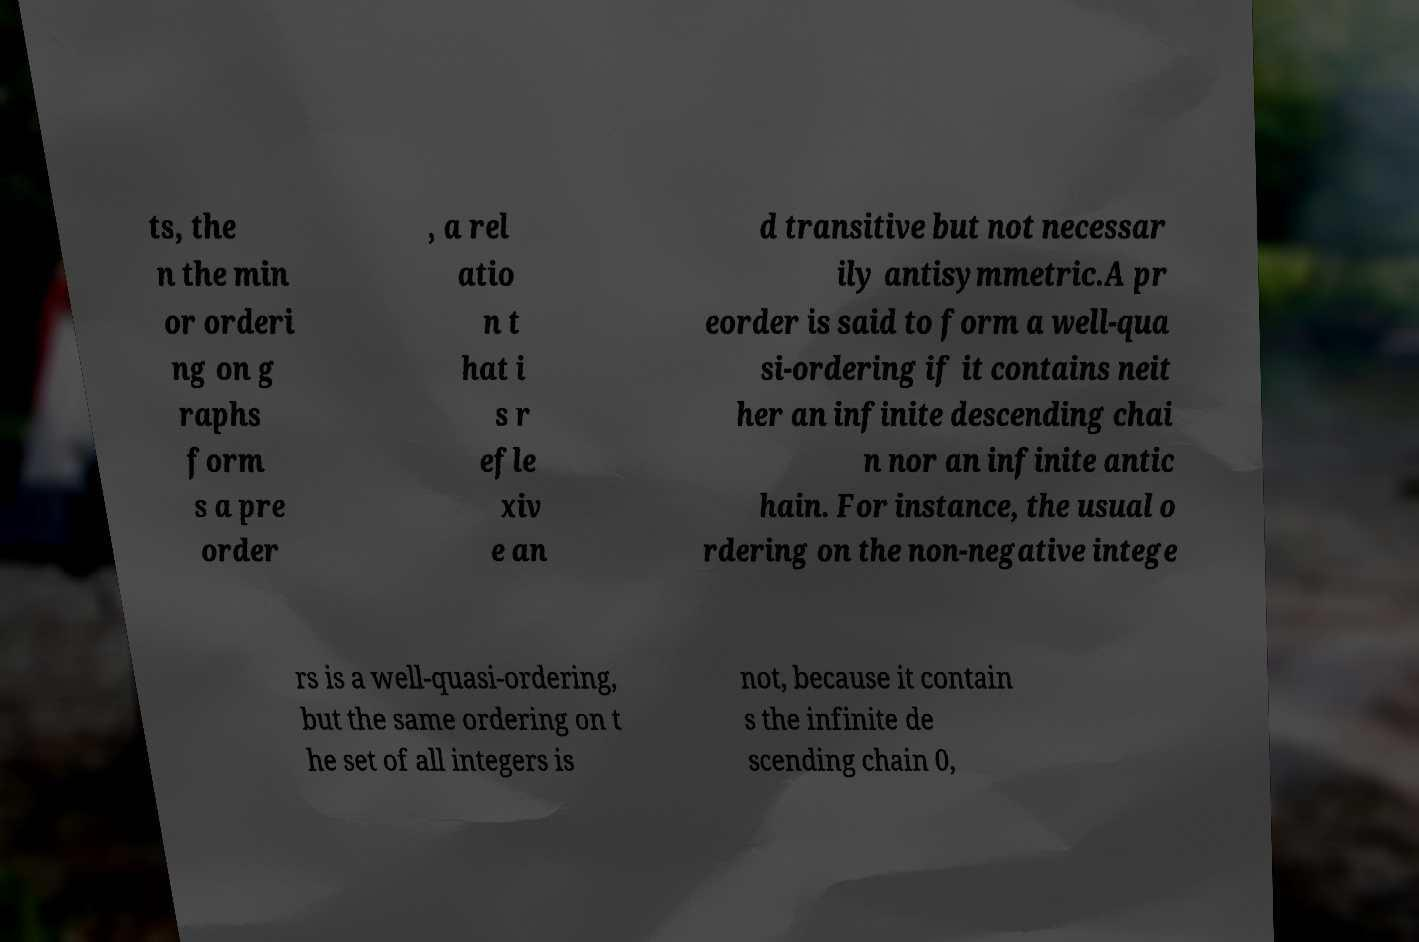I need the written content from this picture converted into text. Can you do that? ts, the n the min or orderi ng on g raphs form s a pre order , a rel atio n t hat i s r efle xiv e an d transitive but not necessar ily antisymmetric.A pr eorder is said to form a well-qua si-ordering if it contains neit her an infinite descending chai n nor an infinite antic hain. For instance, the usual o rdering on the non-negative intege rs is a well-quasi-ordering, but the same ordering on t he set of all integers is not, because it contain s the infinite de scending chain 0, 